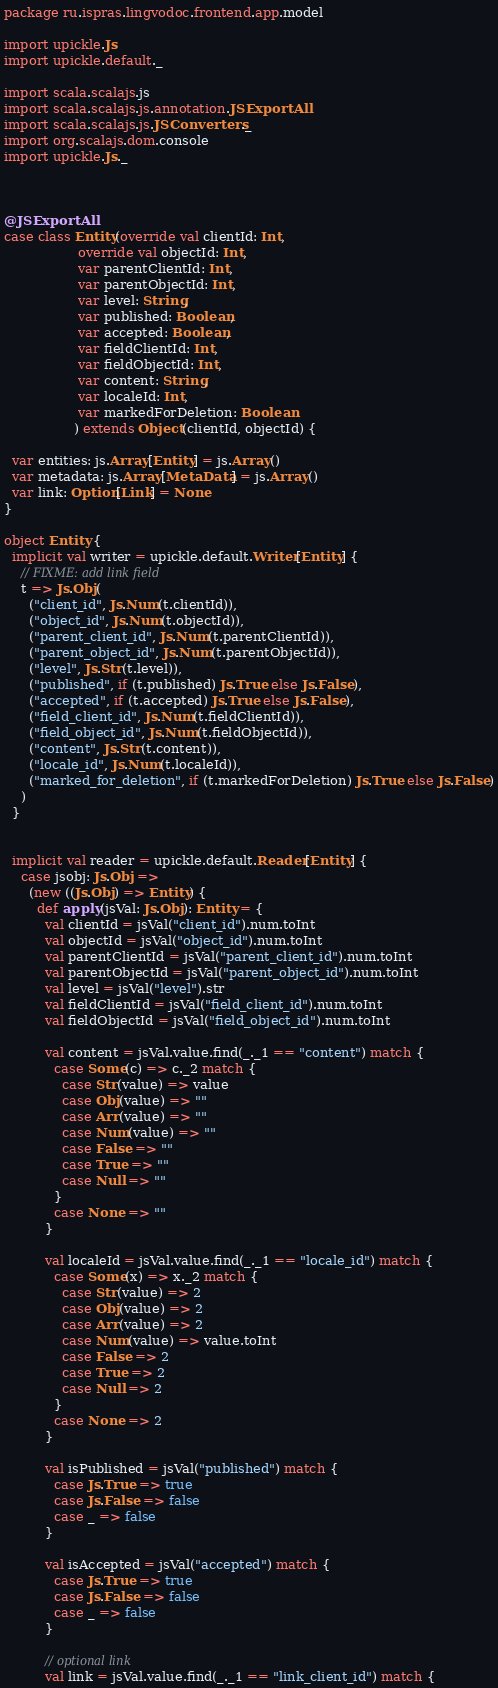Convert code to text. <code><loc_0><loc_0><loc_500><loc_500><_Scala_>package ru.ispras.lingvodoc.frontend.app.model

import upickle.Js
import upickle.default._

import scala.scalajs.js
import scala.scalajs.js.annotation.JSExportAll
import scala.scalajs.js.JSConverters._
import org.scalajs.dom.console
import upickle.Js._



@JSExportAll
case class Entity(override val clientId: Int,
                  override val objectId: Int,
                  var parentClientId: Int,
                  var parentObjectId: Int,
                  var level: String,
                  var published: Boolean,
                  var accepted: Boolean,
                  var fieldClientId: Int,
                  var fieldObjectId: Int,
                  var content: String,
                  var localeId: Int,
                  var markedForDeletion: Boolean
                 ) extends Object(clientId, objectId) {

  var entities: js.Array[Entity] = js.Array()
  var metadata: js.Array[MetaData] = js.Array()
  var link: Option[Link] = None
}

object Entity {
  implicit val writer = upickle.default.Writer[Entity] {
    // FIXME: add link field
    t => Js.Obj(
      ("client_id", Js.Num(t.clientId)),
      ("object_id", Js.Num(t.objectId)),
      ("parent_client_id", Js.Num(t.parentClientId)),
      ("parent_object_id", Js.Num(t.parentObjectId)),
      ("level", Js.Str(t.level)),
      ("published", if (t.published) Js.True else Js.False),
      ("accepted", if (t.accepted) Js.True else Js.False),
      ("field_client_id", Js.Num(t.fieldClientId)),
      ("field_object_id", Js.Num(t.fieldObjectId)),
      ("content", Js.Str(t.content)),
      ("locale_id", Js.Num(t.localeId)),
      ("marked_for_deletion", if (t.markedForDeletion) Js.True else Js.False)
    )
  }


  implicit val reader = upickle.default.Reader[Entity] {
    case jsobj: Js.Obj =>
      (new ((Js.Obj) => Entity) {
        def apply(jsVal: Js.Obj): Entity = {
          val clientId = jsVal("client_id").num.toInt
          val objectId = jsVal("object_id").num.toInt
          val parentClientId = jsVal("parent_client_id").num.toInt
          val parentObjectId = jsVal("parent_object_id").num.toInt
          val level = jsVal("level").str
          val fieldClientId = jsVal("field_client_id").num.toInt
          val fieldObjectId = jsVal("field_object_id").num.toInt

          val content = jsVal.value.find(_._1 == "content") match {
            case Some(c) => c._2 match {
              case Str(value) => value
              case Obj(value) => ""
              case Arr(value) => ""
              case Num(value) => ""
              case False => ""
              case True => ""
              case Null => ""
            }
            case None => ""
          }

          val localeId = jsVal.value.find(_._1 == "locale_id") match {
            case Some(x) => x._2 match {
              case Str(value) => 2
              case Obj(value) => 2
              case Arr(value) => 2
              case Num(value) => value.toInt
              case False => 2
              case True => 2
              case Null => 2
            }
            case None => 2
          }

          val isPublished = jsVal("published") match {
            case Js.True => true
            case Js.False => false
            case _ => false
          }

          val isAccepted = jsVal("accepted") match {
            case Js.True => true
            case Js.False => false
            case _ => false
          }

          // optional link
          val link = jsVal.value.find(_._1 == "link_client_id") match {</code> 